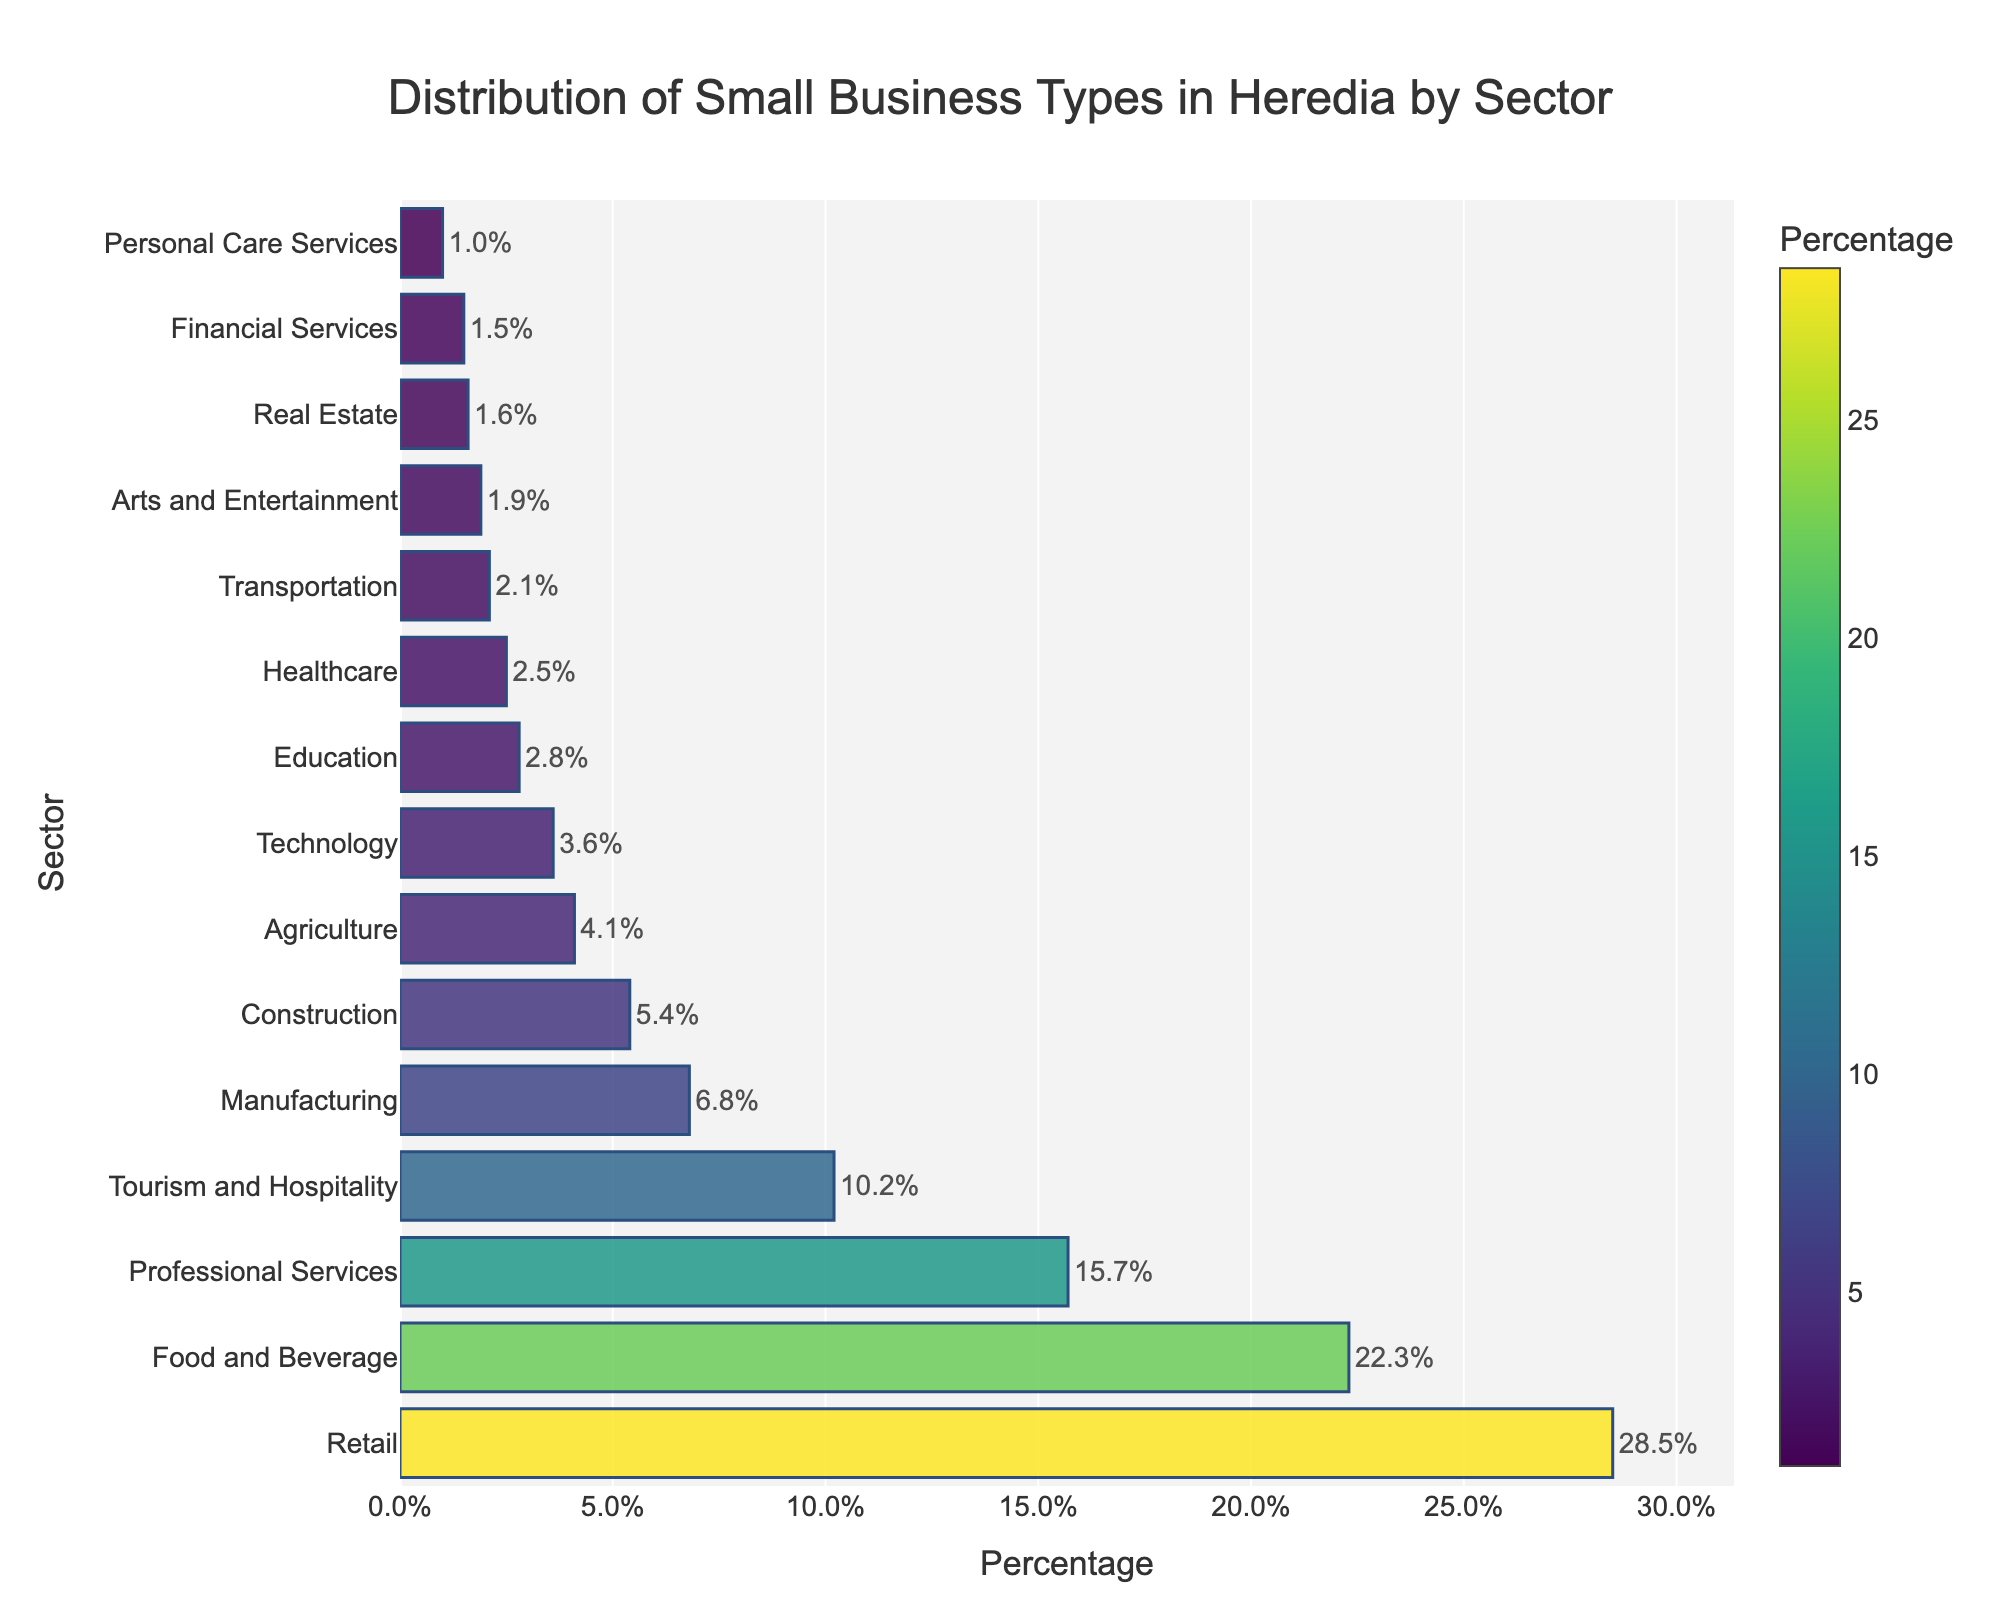What's the percentage of small businesses in the Retail sector compared to the Technology sector? According to the figure, Retail has 28.5% and Technology has 3.6%. Subtracting these values, 28.5% - 3.6% = 24.9%.
Answer: 24.9% Which sector has the highest percentage of small businesses? By visually inspecting the bar chart, the Retail sector has the longest bar, indicating it has the highest percentage.
Answer: Retail How many sectors have a percentage less than 5%? Observing the shorter bars, we count the sectors with values less than 5%. They are Construction (5.4%), Agriculture (4.1%), Technology (3.6%), Education (2.8%), Healthcare (2.5%), Transportation (2.1%), Arts and Entertainment (1.9%), Real Estate (1.6%), Financial Services (1.5%), Personal Care Services (1.0%). There are 9 sectors.
Answer: 9 What's the total percentage of the top three sectors? Summing the percentages of Retail (28.5%), Food and Beverage (22.3%), and Professional Services (15.7%): 28.5 + 22.3 + 15.7 = 66.5%.
Answer: 66.5% Which sector is just above Financial Services in the percentage? In the bar chart sorted by percentage, Real Estate is positioned just above Financial Services (1.5%) with a percentage of 1.6%.
Answer: Real Estate By how much does the percentage of the Food and Beverage sector exceed the Agriculture sector? Subtract the percentage of Agriculture (4.1%) from Food and Beverage (22.3%): 22.3 - 4.1 = 18.2%.
Answer: 18.2% What's the difference in percentage between the Manufacturing and Construction sectors? Subtract the percentage of Construction (5.4%) from Manufacturing (6.8%): 6.8 - 5.4 = 1.4%.
Answer: 1.4% Which sector accounts for more small businesses: Healthcare or Transportation? By comparing visually, Healthcare has a bar at 2.5% and Transportation at 2.1%. Healthcare has a higher percentage.
Answer: Healthcare How does the percentage of the Professional Services sector compare to that of the Tourism and Hospitality sector? Professional Services have a bar at 15.7%, whereas Tourism and Hospitality have a bar at 10.2%. Professional Services has a greater percentage.
Answer: Professional Services 